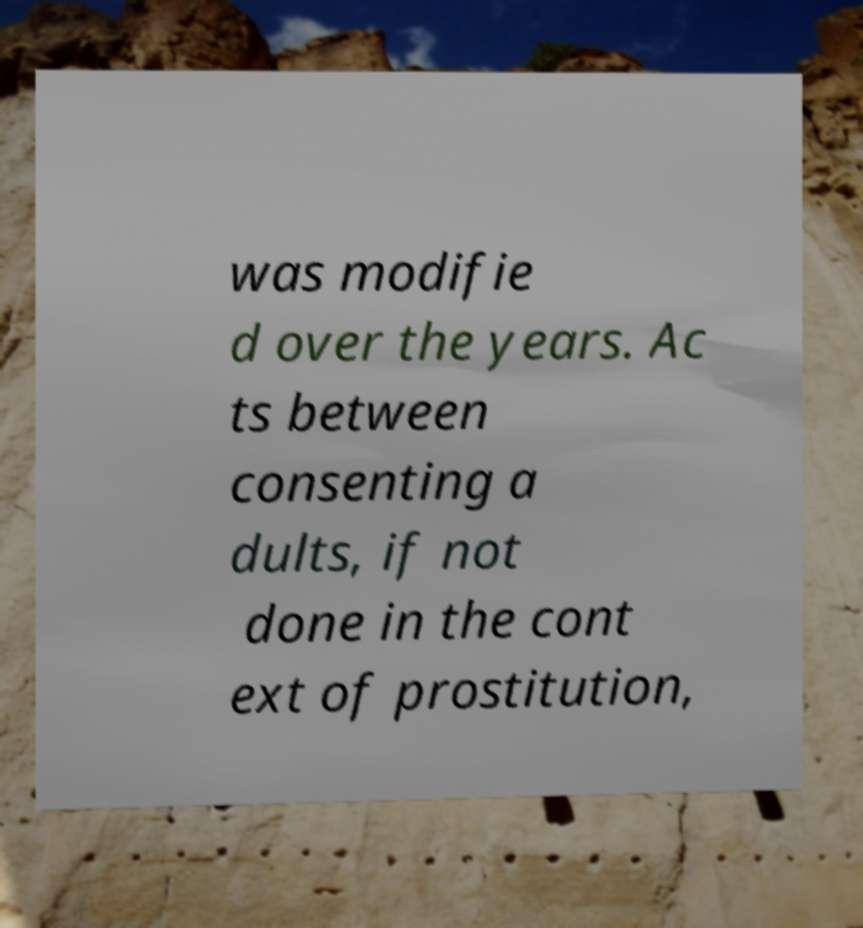Please read and relay the text visible in this image. What does it say? was modifie d over the years. Ac ts between consenting a dults, if not done in the cont ext of prostitution, 